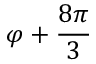<formula> <loc_0><loc_0><loc_500><loc_500>\varphi + \frac { 8 \pi } { 3 }</formula> 